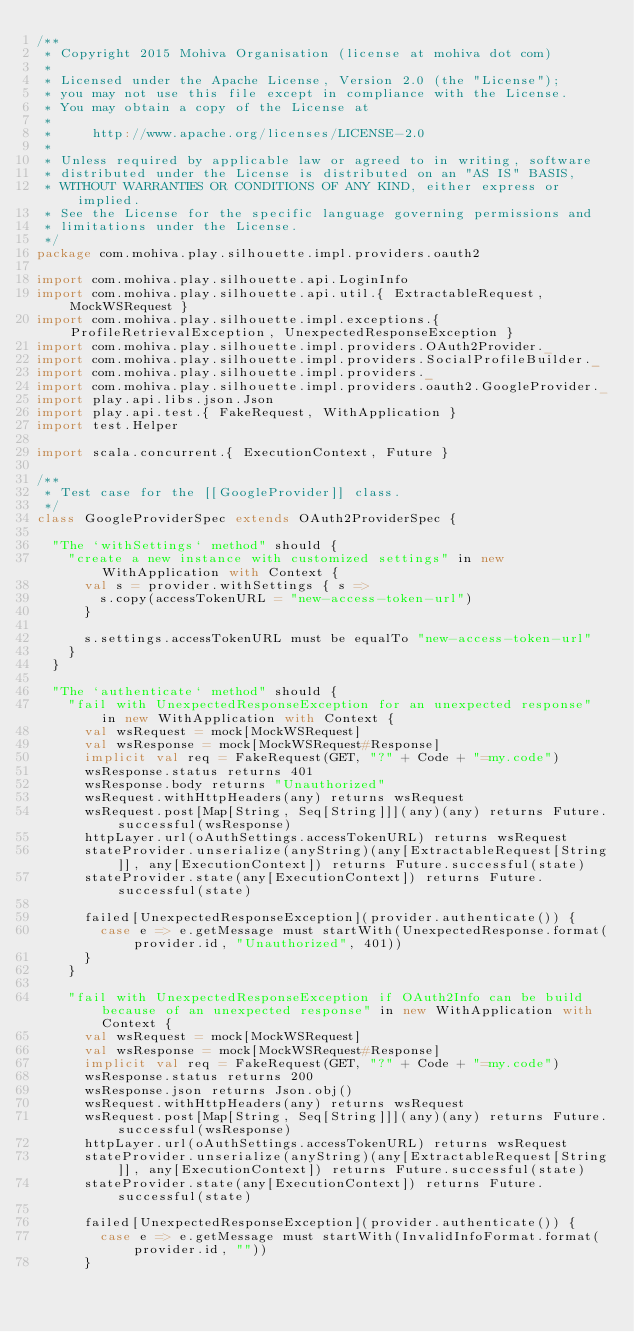<code> <loc_0><loc_0><loc_500><loc_500><_Scala_>/**
 * Copyright 2015 Mohiva Organisation (license at mohiva dot com)
 *
 * Licensed under the Apache License, Version 2.0 (the "License");
 * you may not use this file except in compliance with the License.
 * You may obtain a copy of the License at
 *
 *     http://www.apache.org/licenses/LICENSE-2.0
 *
 * Unless required by applicable law or agreed to in writing, software
 * distributed under the License is distributed on an "AS IS" BASIS,
 * WITHOUT WARRANTIES OR CONDITIONS OF ANY KIND, either express or implied.
 * See the License for the specific language governing permissions and
 * limitations under the License.
 */
package com.mohiva.play.silhouette.impl.providers.oauth2

import com.mohiva.play.silhouette.api.LoginInfo
import com.mohiva.play.silhouette.api.util.{ ExtractableRequest, MockWSRequest }
import com.mohiva.play.silhouette.impl.exceptions.{ ProfileRetrievalException, UnexpectedResponseException }
import com.mohiva.play.silhouette.impl.providers.OAuth2Provider._
import com.mohiva.play.silhouette.impl.providers.SocialProfileBuilder._
import com.mohiva.play.silhouette.impl.providers._
import com.mohiva.play.silhouette.impl.providers.oauth2.GoogleProvider._
import play.api.libs.json.Json
import play.api.test.{ FakeRequest, WithApplication }
import test.Helper

import scala.concurrent.{ ExecutionContext, Future }

/**
 * Test case for the [[GoogleProvider]] class.
 */
class GoogleProviderSpec extends OAuth2ProviderSpec {

  "The `withSettings` method" should {
    "create a new instance with customized settings" in new WithApplication with Context {
      val s = provider.withSettings { s =>
        s.copy(accessTokenURL = "new-access-token-url")
      }

      s.settings.accessTokenURL must be equalTo "new-access-token-url"
    }
  }

  "The `authenticate` method" should {
    "fail with UnexpectedResponseException for an unexpected response" in new WithApplication with Context {
      val wsRequest = mock[MockWSRequest]
      val wsResponse = mock[MockWSRequest#Response]
      implicit val req = FakeRequest(GET, "?" + Code + "=my.code")
      wsResponse.status returns 401
      wsResponse.body returns "Unauthorized"
      wsRequest.withHttpHeaders(any) returns wsRequest
      wsRequest.post[Map[String, Seq[String]]](any)(any) returns Future.successful(wsResponse)
      httpLayer.url(oAuthSettings.accessTokenURL) returns wsRequest
      stateProvider.unserialize(anyString)(any[ExtractableRequest[String]], any[ExecutionContext]) returns Future.successful(state)
      stateProvider.state(any[ExecutionContext]) returns Future.successful(state)

      failed[UnexpectedResponseException](provider.authenticate()) {
        case e => e.getMessage must startWith(UnexpectedResponse.format(provider.id, "Unauthorized", 401))
      }
    }

    "fail with UnexpectedResponseException if OAuth2Info can be build because of an unexpected response" in new WithApplication with Context {
      val wsRequest = mock[MockWSRequest]
      val wsResponse = mock[MockWSRequest#Response]
      implicit val req = FakeRequest(GET, "?" + Code + "=my.code")
      wsResponse.status returns 200
      wsResponse.json returns Json.obj()
      wsRequest.withHttpHeaders(any) returns wsRequest
      wsRequest.post[Map[String, Seq[String]]](any)(any) returns Future.successful(wsResponse)
      httpLayer.url(oAuthSettings.accessTokenURL) returns wsRequest
      stateProvider.unserialize(anyString)(any[ExtractableRequest[String]], any[ExecutionContext]) returns Future.successful(state)
      stateProvider.state(any[ExecutionContext]) returns Future.successful(state)

      failed[UnexpectedResponseException](provider.authenticate()) {
        case e => e.getMessage must startWith(InvalidInfoFormat.format(provider.id, ""))
      }</code> 